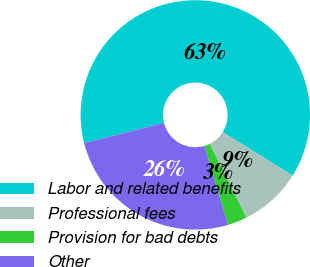Convert chart. <chart><loc_0><loc_0><loc_500><loc_500><pie_chart><fcel>Labor and related benefits<fcel>Professional fees<fcel>Provision for bad debts<fcel>Other<nl><fcel>62.82%<fcel>8.77%<fcel>2.76%<fcel>25.65%<nl></chart> 